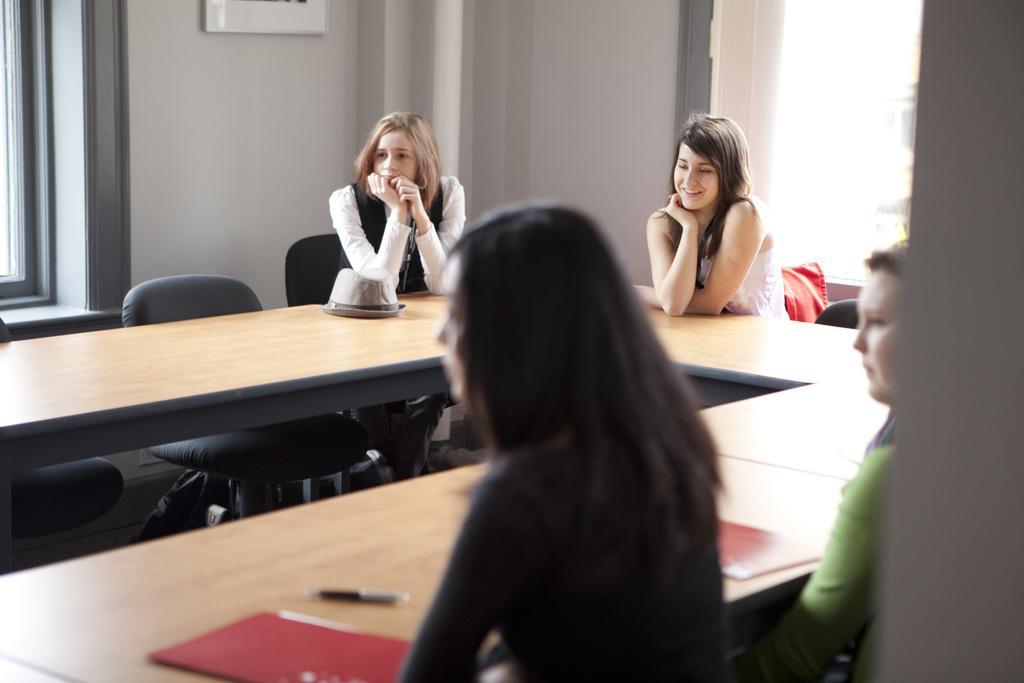How would you summarize this image in a sentence or two? In this picture we can see four persons are sitting on the chairs. This is table. On the table there is a file and a pen. On the background there is a wall. 